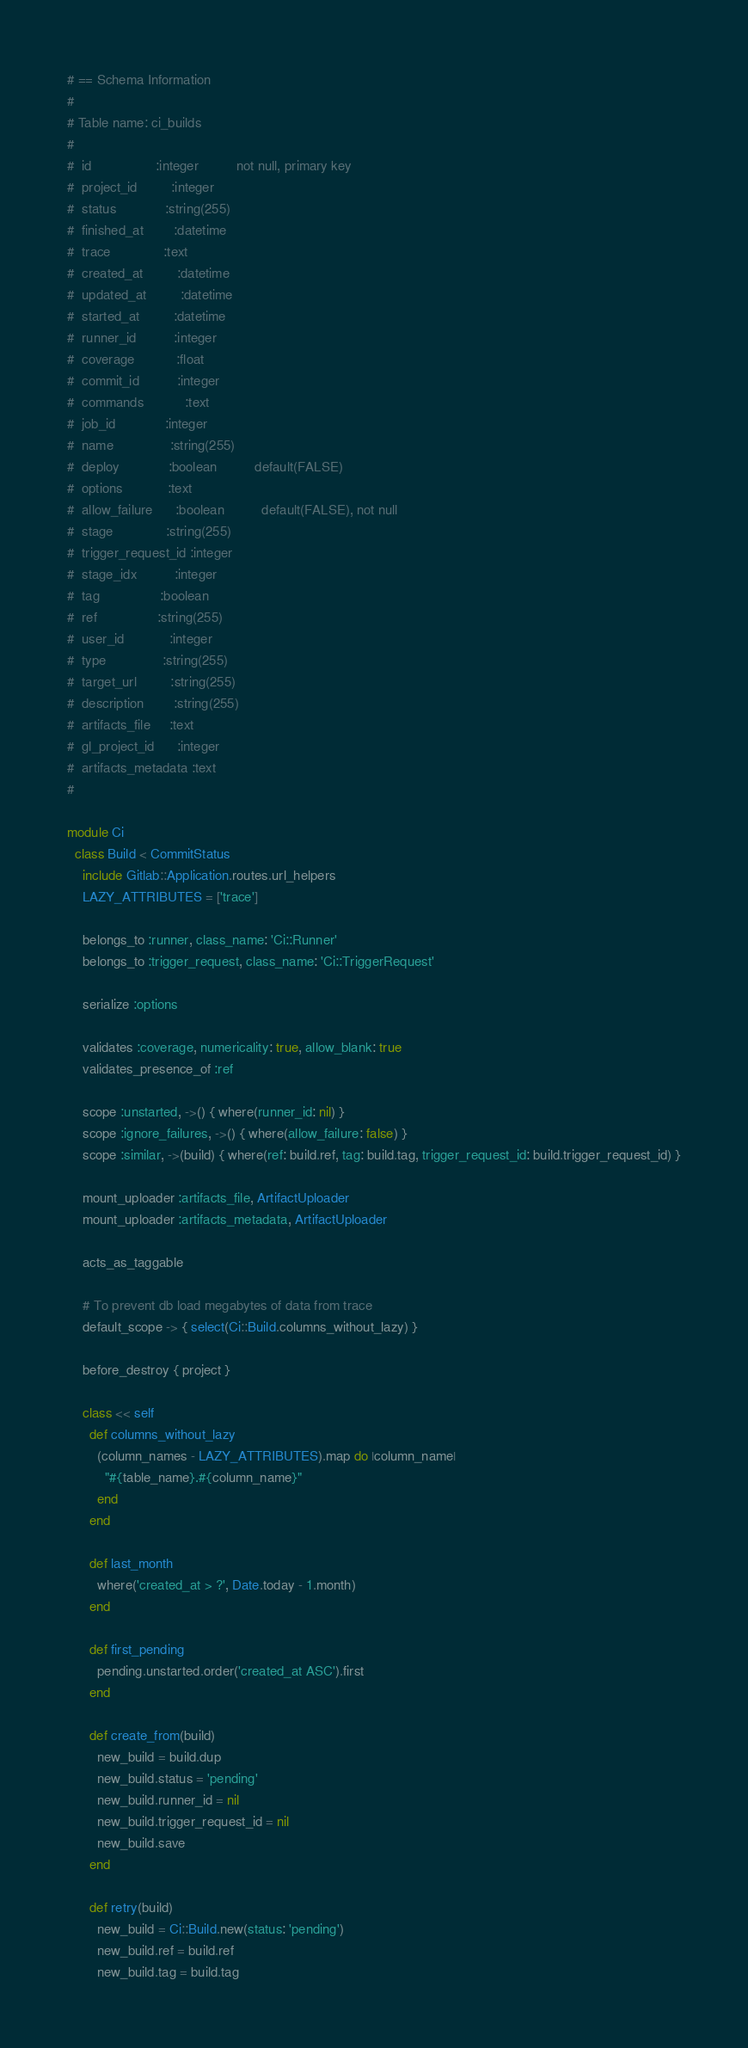<code> <loc_0><loc_0><loc_500><loc_500><_Ruby_># == Schema Information
#
# Table name: ci_builds
#
#  id                 :integer          not null, primary key
#  project_id         :integer
#  status             :string(255)
#  finished_at        :datetime
#  trace              :text
#  created_at         :datetime
#  updated_at         :datetime
#  started_at         :datetime
#  runner_id          :integer
#  coverage           :float
#  commit_id          :integer
#  commands           :text
#  job_id             :integer
#  name               :string(255)
#  deploy             :boolean          default(FALSE)
#  options            :text
#  allow_failure      :boolean          default(FALSE), not null
#  stage              :string(255)
#  trigger_request_id :integer
#  stage_idx          :integer
#  tag                :boolean
#  ref                :string(255)
#  user_id            :integer
#  type               :string(255)
#  target_url         :string(255)
#  description        :string(255)
#  artifacts_file     :text
#  gl_project_id      :integer
#  artifacts_metadata :text
#

module Ci
  class Build < CommitStatus
    include Gitlab::Application.routes.url_helpers
    LAZY_ATTRIBUTES = ['trace']

    belongs_to :runner, class_name: 'Ci::Runner'
    belongs_to :trigger_request, class_name: 'Ci::TriggerRequest'

    serialize :options

    validates :coverage, numericality: true, allow_blank: true
    validates_presence_of :ref

    scope :unstarted, ->() { where(runner_id: nil) }
    scope :ignore_failures, ->() { where(allow_failure: false) }
    scope :similar, ->(build) { where(ref: build.ref, tag: build.tag, trigger_request_id: build.trigger_request_id) }

    mount_uploader :artifacts_file, ArtifactUploader
    mount_uploader :artifacts_metadata, ArtifactUploader

    acts_as_taggable

    # To prevent db load megabytes of data from trace
    default_scope -> { select(Ci::Build.columns_without_lazy) }

    before_destroy { project }

    class << self
      def columns_without_lazy
        (column_names - LAZY_ATTRIBUTES).map do |column_name|
          "#{table_name}.#{column_name}"
        end
      end

      def last_month
        where('created_at > ?', Date.today - 1.month)
      end

      def first_pending
        pending.unstarted.order('created_at ASC').first
      end

      def create_from(build)
        new_build = build.dup
        new_build.status = 'pending'
        new_build.runner_id = nil
        new_build.trigger_request_id = nil
        new_build.save
      end

      def retry(build)
        new_build = Ci::Build.new(status: 'pending')
        new_build.ref = build.ref
        new_build.tag = build.tag</code> 